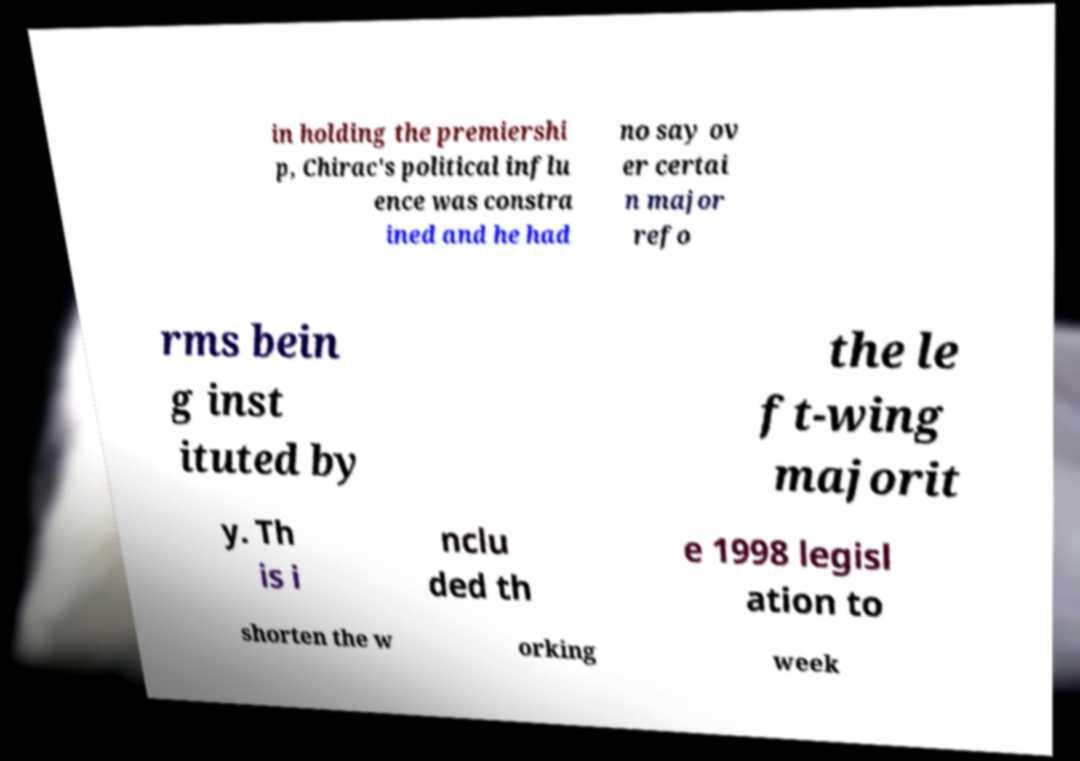Could you extract and type out the text from this image? in holding the premiershi p, Chirac's political influ ence was constra ined and he had no say ov er certai n major refo rms bein g inst ituted by the le ft-wing majorit y. Th is i nclu ded th e 1998 legisl ation to shorten the w orking week 